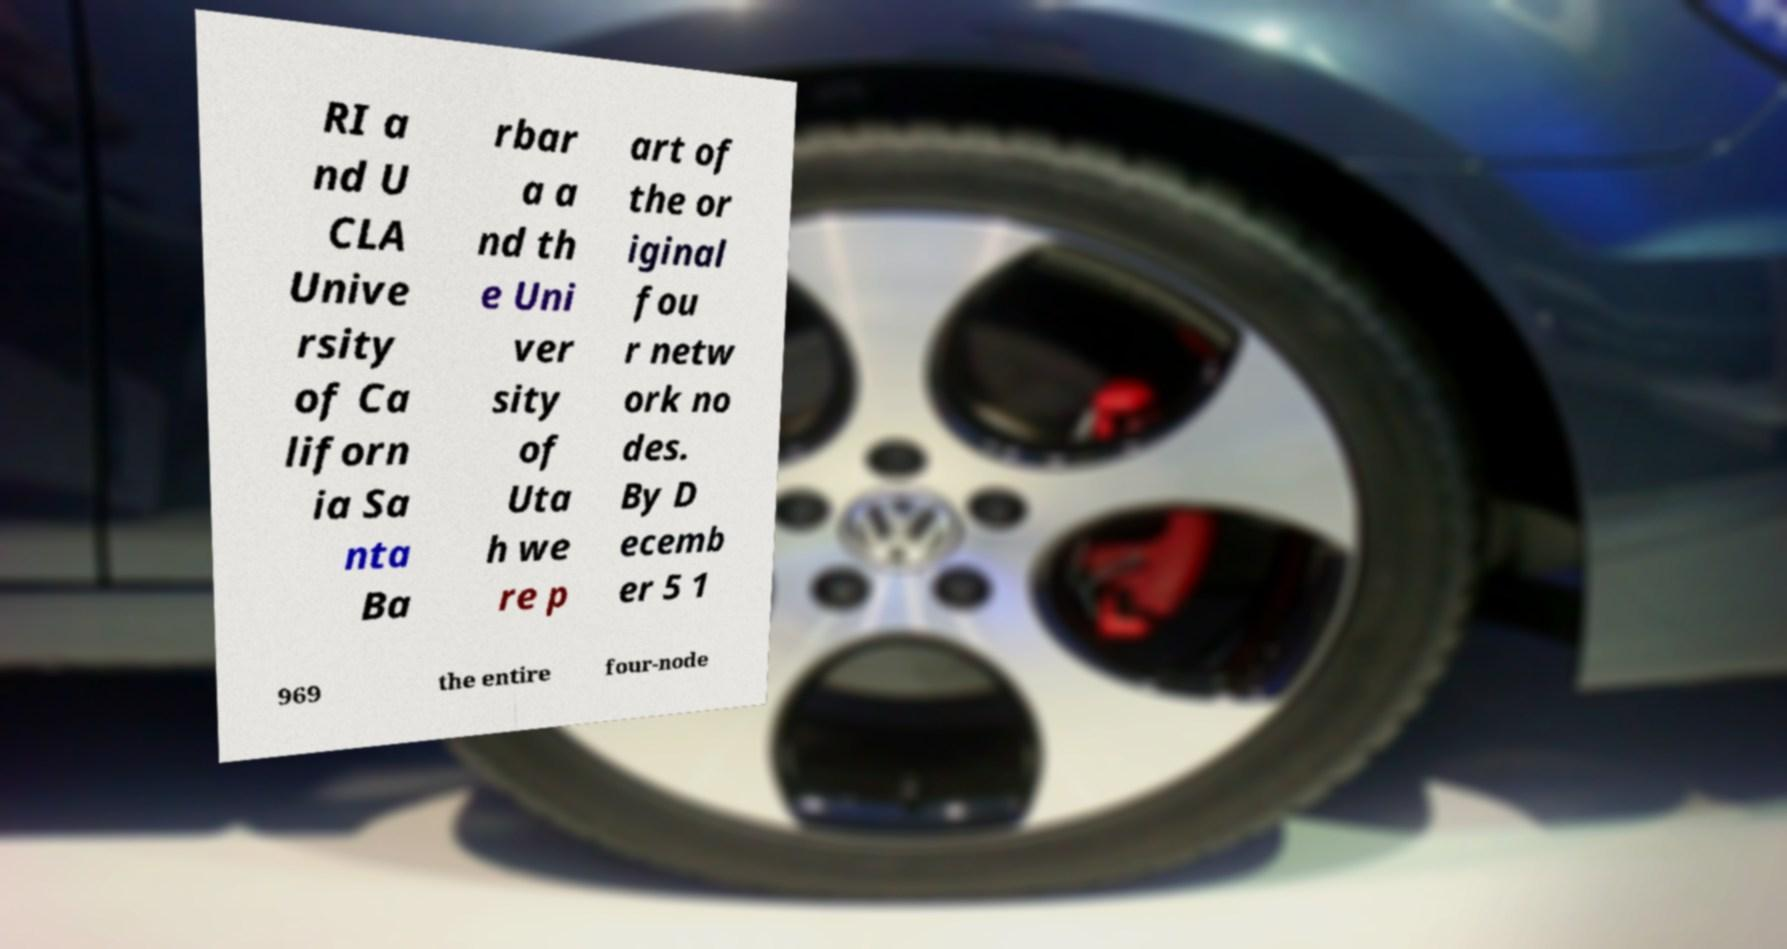Can you read and provide the text displayed in the image?This photo seems to have some interesting text. Can you extract and type it out for me? RI a nd U CLA Unive rsity of Ca liforn ia Sa nta Ba rbar a a nd th e Uni ver sity of Uta h we re p art of the or iginal fou r netw ork no des. By D ecemb er 5 1 969 the entire four-node 